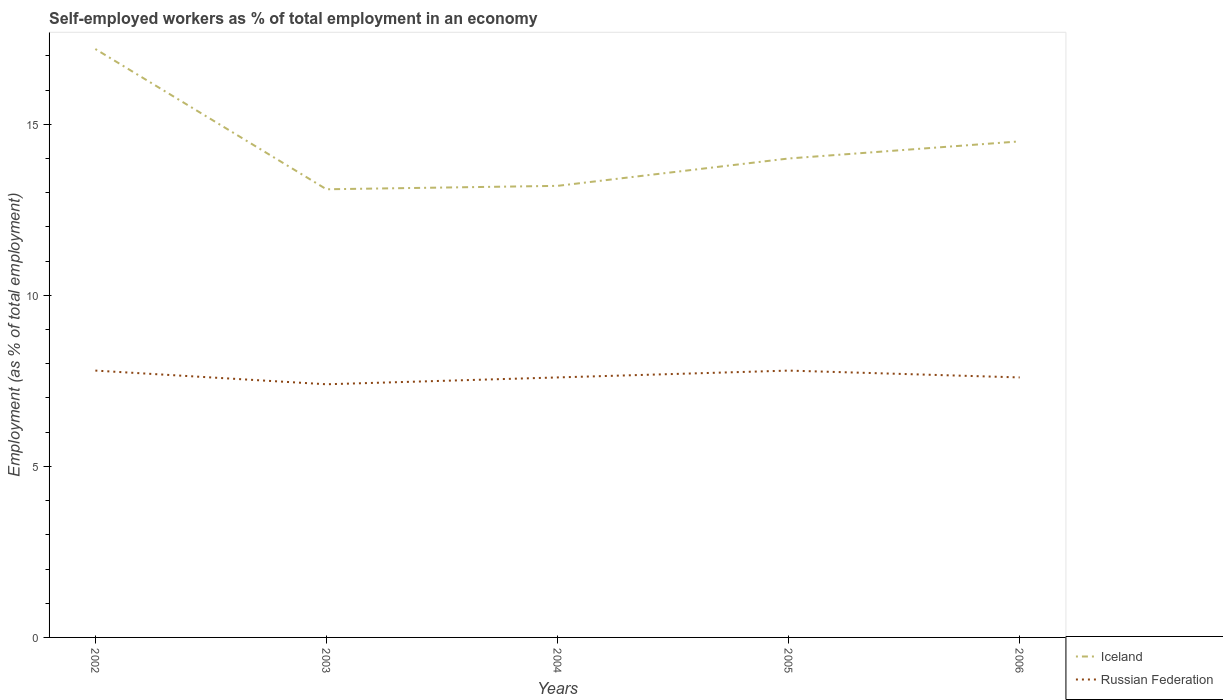How many different coloured lines are there?
Ensure brevity in your answer.  2. Across all years, what is the maximum percentage of self-employed workers in Iceland?
Offer a terse response. 13.1. What is the total percentage of self-employed workers in Iceland in the graph?
Offer a very short reply. 4. What is the difference between the highest and the second highest percentage of self-employed workers in Iceland?
Offer a terse response. 4.1. What is the difference between the highest and the lowest percentage of self-employed workers in Russian Federation?
Keep it short and to the point. 2. Is the percentage of self-employed workers in Iceland strictly greater than the percentage of self-employed workers in Russian Federation over the years?
Your answer should be compact. No. What is the difference between two consecutive major ticks on the Y-axis?
Your response must be concise. 5. Does the graph contain grids?
Ensure brevity in your answer.  No. How many legend labels are there?
Provide a short and direct response. 2. What is the title of the graph?
Your answer should be very brief. Self-employed workers as % of total employment in an economy. What is the label or title of the X-axis?
Offer a very short reply. Years. What is the label or title of the Y-axis?
Make the answer very short. Employment (as % of total employment). What is the Employment (as % of total employment) in Iceland in 2002?
Provide a succinct answer. 17.2. What is the Employment (as % of total employment) in Russian Federation in 2002?
Your answer should be very brief. 7.8. What is the Employment (as % of total employment) in Iceland in 2003?
Give a very brief answer. 13.1. What is the Employment (as % of total employment) in Russian Federation in 2003?
Provide a short and direct response. 7.4. What is the Employment (as % of total employment) in Iceland in 2004?
Offer a very short reply. 13.2. What is the Employment (as % of total employment) of Russian Federation in 2004?
Give a very brief answer. 7.6. What is the Employment (as % of total employment) of Russian Federation in 2005?
Make the answer very short. 7.8. What is the Employment (as % of total employment) of Iceland in 2006?
Provide a short and direct response. 14.5. What is the Employment (as % of total employment) of Russian Federation in 2006?
Your answer should be compact. 7.6. Across all years, what is the maximum Employment (as % of total employment) of Iceland?
Make the answer very short. 17.2. Across all years, what is the maximum Employment (as % of total employment) in Russian Federation?
Provide a short and direct response. 7.8. Across all years, what is the minimum Employment (as % of total employment) of Iceland?
Your answer should be very brief. 13.1. Across all years, what is the minimum Employment (as % of total employment) of Russian Federation?
Ensure brevity in your answer.  7.4. What is the total Employment (as % of total employment) in Russian Federation in the graph?
Your answer should be very brief. 38.2. What is the difference between the Employment (as % of total employment) of Russian Federation in 2002 and that in 2003?
Your response must be concise. 0.4. What is the difference between the Employment (as % of total employment) in Iceland in 2002 and that in 2005?
Provide a short and direct response. 3.2. What is the difference between the Employment (as % of total employment) of Russian Federation in 2002 and that in 2005?
Keep it short and to the point. 0. What is the difference between the Employment (as % of total employment) of Iceland in 2002 and that in 2006?
Your answer should be compact. 2.7. What is the difference between the Employment (as % of total employment) of Russian Federation in 2002 and that in 2006?
Your response must be concise. 0.2. What is the difference between the Employment (as % of total employment) of Russian Federation in 2003 and that in 2004?
Keep it short and to the point. -0.2. What is the difference between the Employment (as % of total employment) of Iceland in 2003 and that in 2006?
Provide a succinct answer. -1.4. What is the difference between the Employment (as % of total employment) of Russian Federation in 2003 and that in 2006?
Your answer should be very brief. -0.2. What is the difference between the Employment (as % of total employment) in Russian Federation in 2005 and that in 2006?
Provide a succinct answer. 0.2. What is the difference between the Employment (as % of total employment) in Iceland in 2002 and the Employment (as % of total employment) in Russian Federation in 2004?
Your answer should be very brief. 9.6. What is the difference between the Employment (as % of total employment) in Iceland in 2002 and the Employment (as % of total employment) in Russian Federation in 2005?
Provide a succinct answer. 9.4. What is the difference between the Employment (as % of total employment) in Iceland in 2002 and the Employment (as % of total employment) in Russian Federation in 2006?
Offer a terse response. 9.6. What is the difference between the Employment (as % of total employment) in Iceland in 2003 and the Employment (as % of total employment) in Russian Federation in 2004?
Ensure brevity in your answer.  5.5. What is the difference between the Employment (as % of total employment) in Iceland in 2003 and the Employment (as % of total employment) in Russian Federation in 2006?
Your answer should be very brief. 5.5. What is the difference between the Employment (as % of total employment) of Iceland in 2004 and the Employment (as % of total employment) of Russian Federation in 2005?
Make the answer very short. 5.4. What is the difference between the Employment (as % of total employment) of Iceland in 2005 and the Employment (as % of total employment) of Russian Federation in 2006?
Your answer should be very brief. 6.4. What is the average Employment (as % of total employment) of Iceland per year?
Your answer should be very brief. 14.4. What is the average Employment (as % of total employment) of Russian Federation per year?
Offer a very short reply. 7.64. In the year 2002, what is the difference between the Employment (as % of total employment) in Iceland and Employment (as % of total employment) in Russian Federation?
Provide a succinct answer. 9.4. In the year 2003, what is the difference between the Employment (as % of total employment) of Iceland and Employment (as % of total employment) of Russian Federation?
Provide a succinct answer. 5.7. In the year 2005, what is the difference between the Employment (as % of total employment) of Iceland and Employment (as % of total employment) of Russian Federation?
Your answer should be compact. 6.2. In the year 2006, what is the difference between the Employment (as % of total employment) of Iceland and Employment (as % of total employment) of Russian Federation?
Offer a terse response. 6.9. What is the ratio of the Employment (as % of total employment) of Iceland in 2002 to that in 2003?
Provide a short and direct response. 1.31. What is the ratio of the Employment (as % of total employment) in Russian Federation in 2002 to that in 2003?
Your answer should be compact. 1.05. What is the ratio of the Employment (as % of total employment) of Iceland in 2002 to that in 2004?
Keep it short and to the point. 1.3. What is the ratio of the Employment (as % of total employment) of Russian Federation in 2002 to that in 2004?
Your answer should be compact. 1.03. What is the ratio of the Employment (as % of total employment) of Iceland in 2002 to that in 2005?
Your answer should be very brief. 1.23. What is the ratio of the Employment (as % of total employment) in Russian Federation in 2002 to that in 2005?
Provide a succinct answer. 1. What is the ratio of the Employment (as % of total employment) of Iceland in 2002 to that in 2006?
Your answer should be compact. 1.19. What is the ratio of the Employment (as % of total employment) in Russian Federation in 2002 to that in 2006?
Offer a very short reply. 1.03. What is the ratio of the Employment (as % of total employment) of Iceland in 2003 to that in 2004?
Your response must be concise. 0.99. What is the ratio of the Employment (as % of total employment) in Russian Federation in 2003 to that in 2004?
Ensure brevity in your answer.  0.97. What is the ratio of the Employment (as % of total employment) in Iceland in 2003 to that in 2005?
Your response must be concise. 0.94. What is the ratio of the Employment (as % of total employment) of Russian Federation in 2003 to that in 2005?
Your response must be concise. 0.95. What is the ratio of the Employment (as % of total employment) of Iceland in 2003 to that in 2006?
Provide a short and direct response. 0.9. What is the ratio of the Employment (as % of total employment) of Russian Federation in 2003 to that in 2006?
Your response must be concise. 0.97. What is the ratio of the Employment (as % of total employment) in Iceland in 2004 to that in 2005?
Keep it short and to the point. 0.94. What is the ratio of the Employment (as % of total employment) of Russian Federation in 2004 to that in 2005?
Make the answer very short. 0.97. What is the ratio of the Employment (as % of total employment) of Iceland in 2004 to that in 2006?
Your answer should be compact. 0.91. What is the ratio of the Employment (as % of total employment) of Iceland in 2005 to that in 2006?
Keep it short and to the point. 0.97. What is the ratio of the Employment (as % of total employment) in Russian Federation in 2005 to that in 2006?
Make the answer very short. 1.03. What is the difference between the highest and the lowest Employment (as % of total employment) of Russian Federation?
Your answer should be very brief. 0.4. 